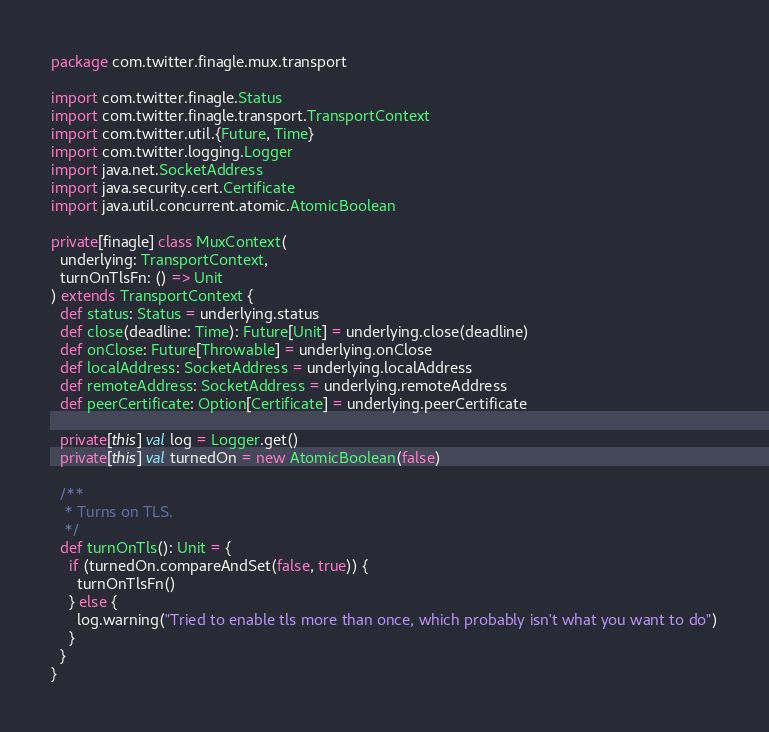Convert code to text. <code><loc_0><loc_0><loc_500><loc_500><_Scala_>package com.twitter.finagle.mux.transport

import com.twitter.finagle.Status
import com.twitter.finagle.transport.TransportContext
import com.twitter.util.{Future, Time}
import com.twitter.logging.Logger
import java.net.SocketAddress
import java.security.cert.Certificate
import java.util.concurrent.atomic.AtomicBoolean

private[finagle] class MuxContext(
  underlying: TransportContext,
  turnOnTlsFn: () => Unit
) extends TransportContext {
  def status: Status = underlying.status
  def close(deadline: Time): Future[Unit] = underlying.close(deadline)
  def onClose: Future[Throwable] = underlying.onClose
  def localAddress: SocketAddress = underlying.localAddress
  def remoteAddress: SocketAddress = underlying.remoteAddress
  def peerCertificate: Option[Certificate] = underlying.peerCertificate

  private[this] val log = Logger.get()
  private[this] val turnedOn = new AtomicBoolean(false)

  /**
   * Turns on TLS.
   */
  def turnOnTls(): Unit = {
    if (turnedOn.compareAndSet(false, true)) {
      turnOnTlsFn()
    } else {
      log.warning("Tried to enable tls more than once, which probably isn't what you want to do")
    }
  }
}
</code> 